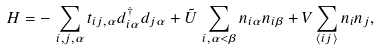Convert formula to latex. <formula><loc_0><loc_0><loc_500><loc_500>H = - \, \sum _ { i , j , \alpha } t _ { i j , \alpha } d _ { i \alpha } ^ { \dagger } { d } _ { j \alpha } + \tilde { U } \, \sum _ { i , \alpha < \beta } n _ { i \alpha } n _ { i \beta } + V \sum _ { \langle i j \rangle } n _ { i } n _ { j } ,</formula> 